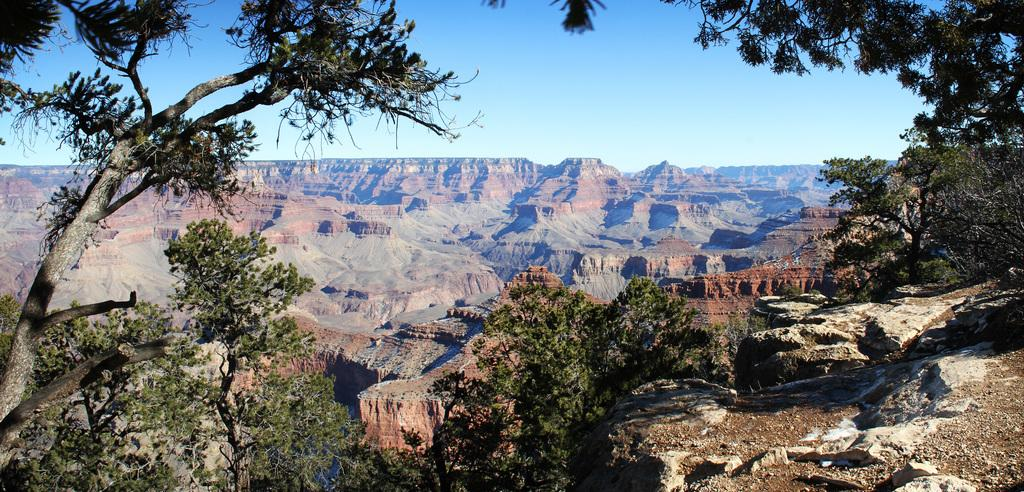What type of geographical feature can be seen in the image? The image contains plateaus. What type of vegetation is present in the image? There are trees with branches and leaves in the image. What part of the natural environment is visible in the image? The sky is visible in the image. Can you see any fairies flying around the trees in the image? There are no fairies present in the image; it only features plateaus, trees, and the sky. Is there any salt visible on the plateaus in the image? There is no salt present in the image; it only features plateaus, trees, and the sky. 